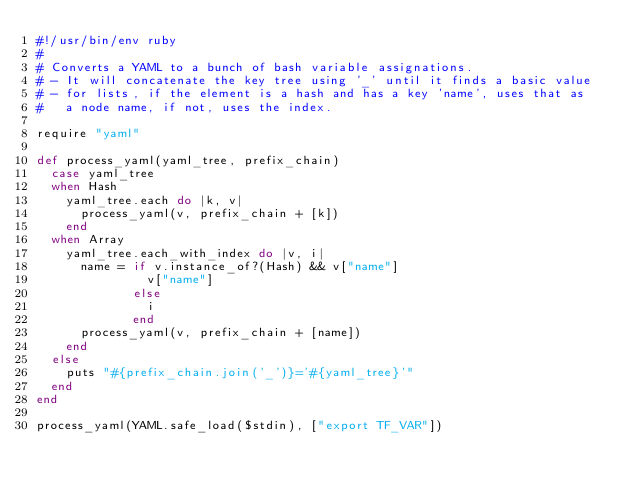Convert code to text. <code><loc_0><loc_0><loc_500><loc_500><_Ruby_>#!/usr/bin/env ruby
#
# Converts a YAML to a bunch of bash variable assignations.
# - It will concatenate the key tree using '_' until it finds a basic value
# - for lists, if the element is a hash and has a key 'name', uses that as
#   a node name, if not, uses the index.

require "yaml"

def process_yaml(yaml_tree, prefix_chain)
  case yaml_tree
  when Hash
    yaml_tree.each do |k, v|
      process_yaml(v, prefix_chain + [k])
    end
  when Array
    yaml_tree.each_with_index do |v, i|
      name = if v.instance_of?(Hash) && v["name"]
               v["name"]
             else
               i
             end
      process_yaml(v, prefix_chain + [name])
    end
  else
    puts "#{prefix_chain.join('_')}='#{yaml_tree}'"
  end
end

process_yaml(YAML.safe_load($stdin), ["export TF_VAR"])
</code> 